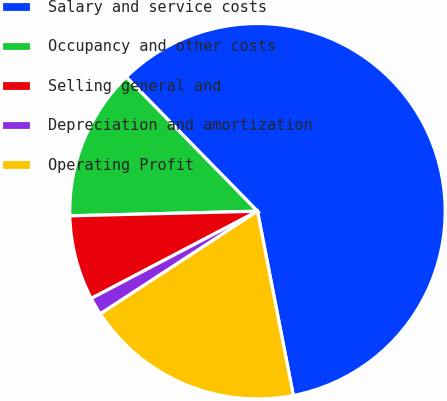Convert chart. <chart><loc_0><loc_0><loc_500><loc_500><pie_chart><fcel>Salary and service costs<fcel>Occupancy and other costs<fcel>Selling general and<fcel>Depreciation and amortization<fcel>Operating Profit<nl><fcel>59.27%<fcel>13.07%<fcel>7.3%<fcel>1.52%<fcel>18.85%<nl></chart> 